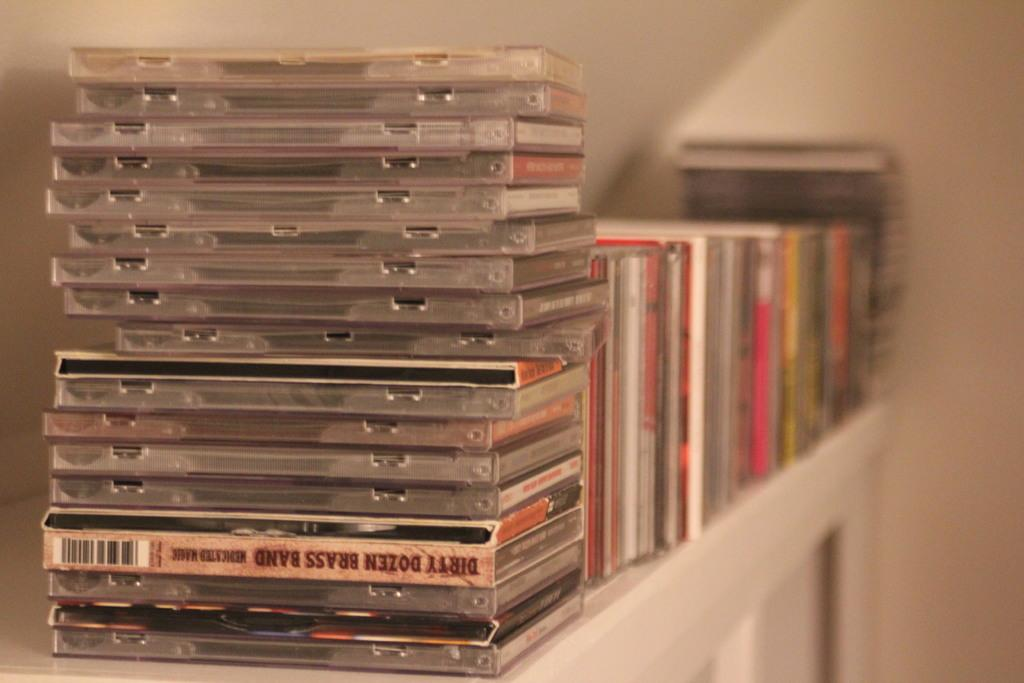<image>
Create a compact narrative representing the image presented. large stack of cds including dirty dozen brassband on a white table or shelf 